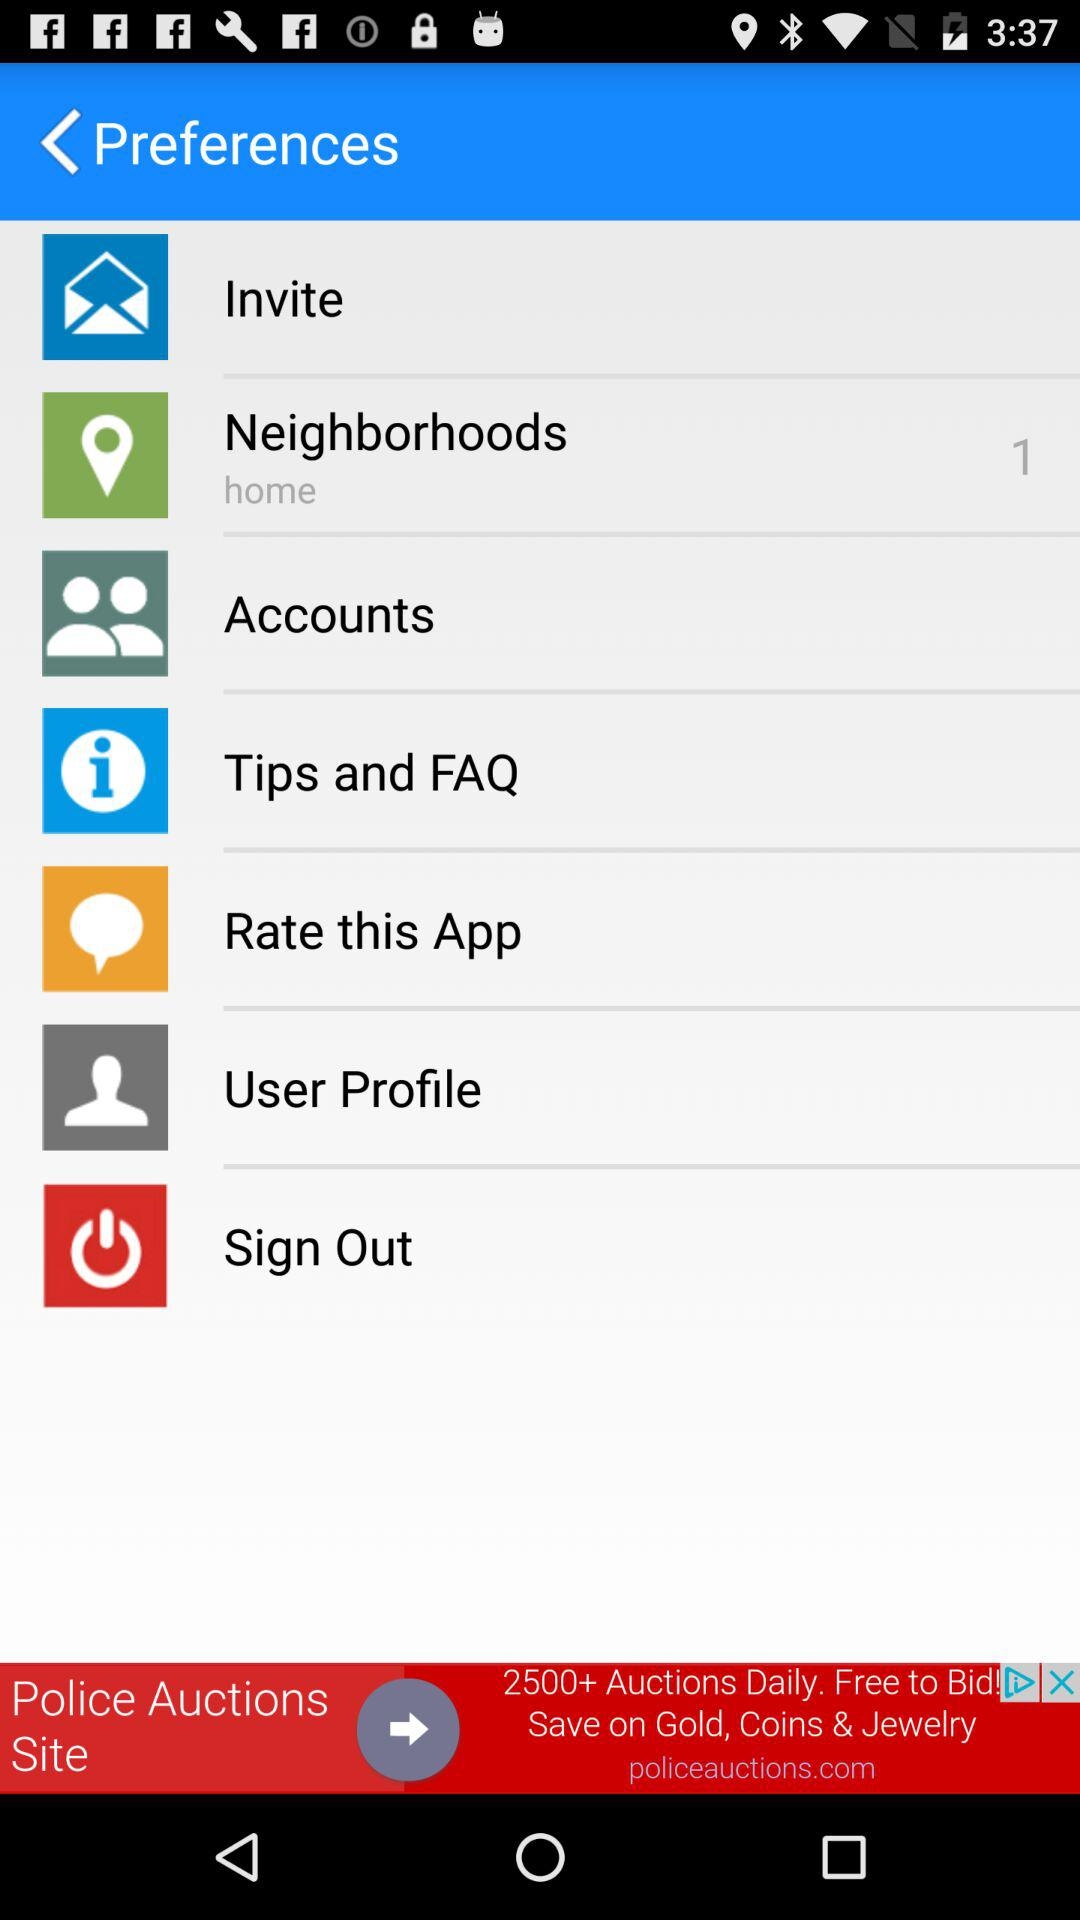How many notifications are pending for neighborhoods? There is 1 notification pending for neighborhoods. 